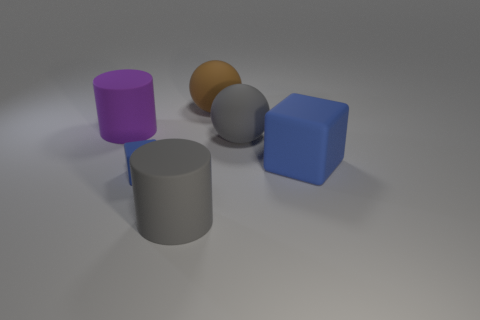Add 2 yellow matte things. How many objects exist? 8 Subtract all cylinders. How many objects are left? 4 Subtract 0 yellow spheres. How many objects are left? 6 Subtract all large purple things. Subtract all tiny red matte cubes. How many objects are left? 5 Add 4 big rubber things. How many big rubber things are left? 9 Add 6 big yellow objects. How many big yellow objects exist? 6 